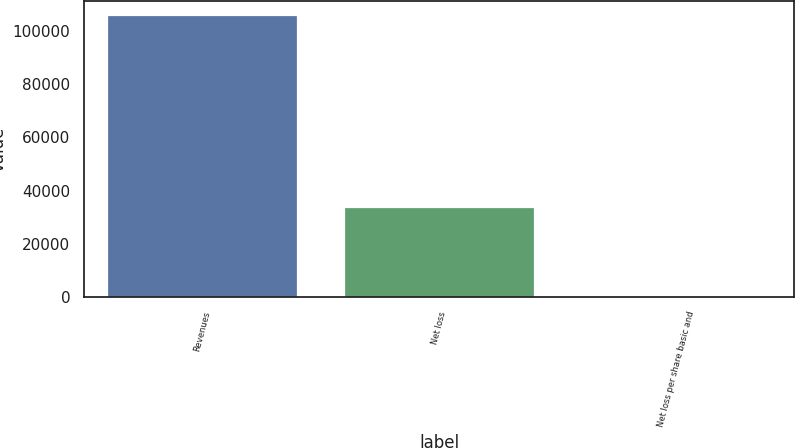Convert chart. <chart><loc_0><loc_0><loc_500><loc_500><bar_chart><fcel>Revenues<fcel>Net loss<fcel>Net loss per share basic and<nl><fcel>105979<fcel>33875<fcel>0.41<nl></chart> 